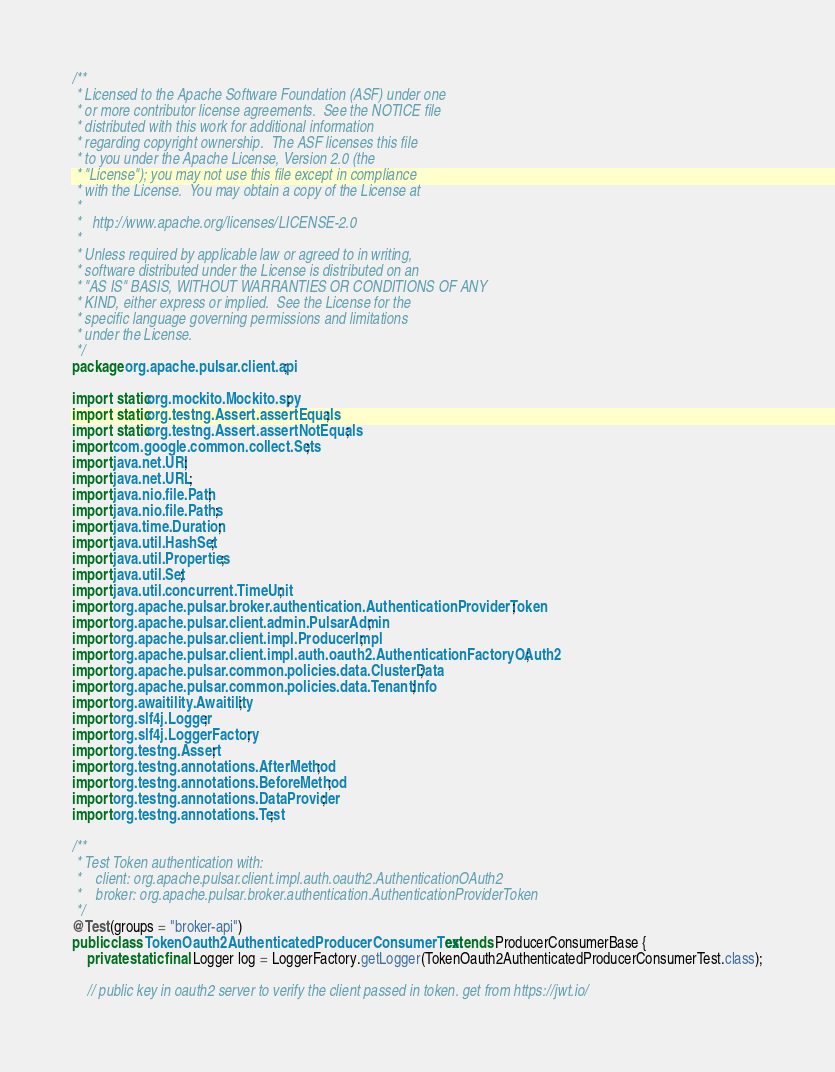Convert code to text. <code><loc_0><loc_0><loc_500><loc_500><_Java_>/**
 * Licensed to the Apache Software Foundation (ASF) under one
 * or more contributor license agreements.  See the NOTICE file
 * distributed with this work for additional information
 * regarding copyright ownership.  The ASF licenses this file
 * to you under the Apache License, Version 2.0 (the
 * "License"); you may not use this file except in compliance
 * with the License.  You may obtain a copy of the License at
 *
 *   http://www.apache.org/licenses/LICENSE-2.0
 *
 * Unless required by applicable law or agreed to in writing,
 * software distributed under the License is distributed on an
 * "AS IS" BASIS, WITHOUT WARRANTIES OR CONDITIONS OF ANY
 * KIND, either express or implied.  See the License for the
 * specific language governing permissions and limitations
 * under the License.
 */
package org.apache.pulsar.client.api;

import static org.mockito.Mockito.spy;
import static org.testng.Assert.assertEquals;
import static org.testng.Assert.assertNotEquals;
import com.google.common.collect.Sets;
import java.net.URI;
import java.net.URL;
import java.nio.file.Path;
import java.nio.file.Paths;
import java.time.Duration;
import java.util.HashSet;
import java.util.Properties;
import java.util.Set;
import java.util.concurrent.TimeUnit;
import org.apache.pulsar.broker.authentication.AuthenticationProviderToken;
import org.apache.pulsar.client.admin.PulsarAdmin;
import org.apache.pulsar.client.impl.ProducerImpl;
import org.apache.pulsar.client.impl.auth.oauth2.AuthenticationFactoryOAuth2;
import org.apache.pulsar.common.policies.data.ClusterData;
import org.apache.pulsar.common.policies.data.TenantInfo;
import org.awaitility.Awaitility;
import org.slf4j.Logger;
import org.slf4j.LoggerFactory;
import org.testng.Assert;
import org.testng.annotations.AfterMethod;
import org.testng.annotations.BeforeMethod;
import org.testng.annotations.DataProvider;
import org.testng.annotations.Test;

/**
 * Test Token authentication with:
 *    client: org.apache.pulsar.client.impl.auth.oauth2.AuthenticationOAuth2
 *    broker: org.apache.pulsar.broker.authentication.AuthenticationProviderToken
 */
@Test(groups = "broker-api")
public class TokenOauth2AuthenticatedProducerConsumerTest extends ProducerConsumerBase {
    private static final Logger log = LoggerFactory.getLogger(TokenOauth2AuthenticatedProducerConsumerTest.class);

    // public key in oauth2 server to verify the client passed in token. get from https://jwt.io/</code> 